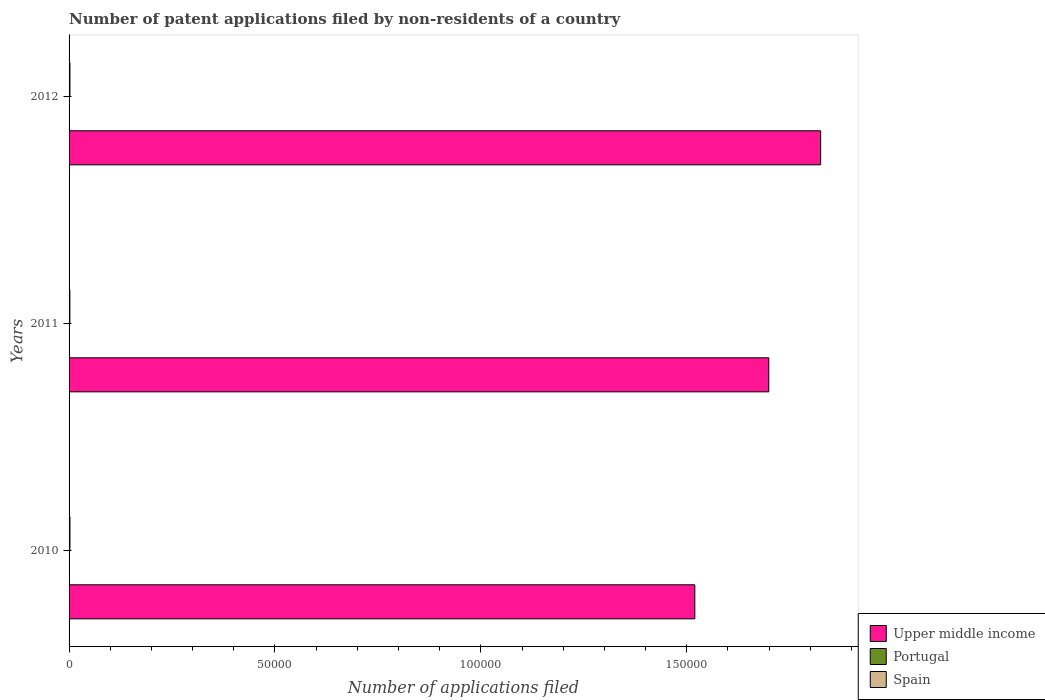Are the number of bars on each tick of the Y-axis equal?
Provide a succinct answer. Yes. How many bars are there on the 1st tick from the top?
Give a very brief answer. 3. How many bars are there on the 3rd tick from the bottom?
Give a very brief answer. 3. In how many cases, is the number of bars for a given year not equal to the number of legend labels?
Provide a short and direct response. 0. Across all years, what is the maximum number of applications filed in Upper middle income?
Offer a very short reply. 1.83e+05. Across all years, what is the minimum number of applications filed in Spain?
Give a very brief answer. 196. In which year was the number of applications filed in Spain minimum?
Your answer should be compact. 2011. What is the total number of applications filed in Portugal in the graph?
Offer a very short reply. 147. What is the difference between the number of applications filed in Spain in 2011 and that in 2012?
Ensure brevity in your answer.  -13. What is the difference between the number of applications filed in Spain in 2011 and the number of applications filed in Upper middle income in 2012?
Provide a short and direct response. -1.82e+05. What is the average number of applications filed in Upper middle income per year?
Ensure brevity in your answer.  1.68e+05. In the year 2010, what is the difference between the number of applications filed in Upper middle income and number of applications filed in Spain?
Provide a short and direct response. 1.52e+05. What is the ratio of the number of applications filed in Portugal in 2010 to that in 2011?
Give a very brief answer. 0.61. Is the number of applications filed in Portugal in 2010 less than that in 2012?
Provide a succinct answer. No. In how many years, is the number of applications filed in Portugal greater than the average number of applications filed in Portugal taken over all years?
Provide a succinct answer. 1. What does the 3rd bar from the top in 2012 represents?
Ensure brevity in your answer.  Upper middle income. How many bars are there?
Make the answer very short. 9. Are all the bars in the graph horizontal?
Your answer should be compact. Yes. What is the difference between two consecutive major ticks on the X-axis?
Ensure brevity in your answer.  5.00e+04. Are the values on the major ticks of X-axis written in scientific E-notation?
Offer a very short reply. No. Does the graph contain any zero values?
Offer a very short reply. No. Where does the legend appear in the graph?
Offer a terse response. Bottom right. How many legend labels are there?
Give a very brief answer. 3. What is the title of the graph?
Provide a short and direct response. Number of patent applications filed by non-residents of a country. What is the label or title of the X-axis?
Keep it short and to the point. Number of applications filed. What is the label or title of the Y-axis?
Offer a very short reply. Years. What is the Number of applications filed of Upper middle income in 2010?
Provide a short and direct response. 1.52e+05. What is the Number of applications filed in Portugal in 2010?
Your response must be concise. 46. What is the Number of applications filed of Spain in 2010?
Give a very brief answer. 213. What is the Number of applications filed in Upper middle income in 2011?
Your response must be concise. 1.70e+05. What is the Number of applications filed in Spain in 2011?
Offer a terse response. 196. What is the Number of applications filed of Upper middle income in 2012?
Your response must be concise. 1.83e+05. What is the Number of applications filed in Spain in 2012?
Your answer should be very brief. 209. Across all years, what is the maximum Number of applications filed of Upper middle income?
Keep it short and to the point. 1.83e+05. Across all years, what is the maximum Number of applications filed in Spain?
Ensure brevity in your answer.  213. Across all years, what is the minimum Number of applications filed of Upper middle income?
Give a very brief answer. 1.52e+05. Across all years, what is the minimum Number of applications filed of Spain?
Give a very brief answer. 196. What is the total Number of applications filed in Upper middle income in the graph?
Offer a very short reply. 5.04e+05. What is the total Number of applications filed of Portugal in the graph?
Provide a short and direct response. 147. What is the total Number of applications filed in Spain in the graph?
Provide a short and direct response. 618. What is the difference between the Number of applications filed in Upper middle income in 2010 and that in 2011?
Your response must be concise. -1.80e+04. What is the difference between the Number of applications filed in Spain in 2010 and that in 2011?
Your answer should be compact. 17. What is the difference between the Number of applications filed in Upper middle income in 2010 and that in 2012?
Your response must be concise. -3.06e+04. What is the difference between the Number of applications filed of Upper middle income in 2011 and that in 2012?
Your response must be concise. -1.26e+04. What is the difference between the Number of applications filed of Upper middle income in 2010 and the Number of applications filed of Portugal in 2011?
Offer a terse response. 1.52e+05. What is the difference between the Number of applications filed of Upper middle income in 2010 and the Number of applications filed of Spain in 2011?
Offer a very short reply. 1.52e+05. What is the difference between the Number of applications filed in Portugal in 2010 and the Number of applications filed in Spain in 2011?
Offer a very short reply. -150. What is the difference between the Number of applications filed of Upper middle income in 2010 and the Number of applications filed of Portugal in 2012?
Make the answer very short. 1.52e+05. What is the difference between the Number of applications filed in Upper middle income in 2010 and the Number of applications filed in Spain in 2012?
Your response must be concise. 1.52e+05. What is the difference between the Number of applications filed of Portugal in 2010 and the Number of applications filed of Spain in 2012?
Ensure brevity in your answer.  -163. What is the difference between the Number of applications filed in Upper middle income in 2011 and the Number of applications filed in Portugal in 2012?
Your answer should be compact. 1.70e+05. What is the difference between the Number of applications filed of Upper middle income in 2011 and the Number of applications filed of Spain in 2012?
Your response must be concise. 1.70e+05. What is the difference between the Number of applications filed of Portugal in 2011 and the Number of applications filed of Spain in 2012?
Your answer should be compact. -134. What is the average Number of applications filed in Upper middle income per year?
Give a very brief answer. 1.68e+05. What is the average Number of applications filed of Portugal per year?
Offer a very short reply. 49. What is the average Number of applications filed in Spain per year?
Provide a succinct answer. 206. In the year 2010, what is the difference between the Number of applications filed in Upper middle income and Number of applications filed in Portugal?
Offer a very short reply. 1.52e+05. In the year 2010, what is the difference between the Number of applications filed in Upper middle income and Number of applications filed in Spain?
Keep it short and to the point. 1.52e+05. In the year 2010, what is the difference between the Number of applications filed of Portugal and Number of applications filed of Spain?
Make the answer very short. -167. In the year 2011, what is the difference between the Number of applications filed of Upper middle income and Number of applications filed of Portugal?
Your answer should be very brief. 1.70e+05. In the year 2011, what is the difference between the Number of applications filed in Upper middle income and Number of applications filed in Spain?
Your answer should be very brief. 1.70e+05. In the year 2011, what is the difference between the Number of applications filed of Portugal and Number of applications filed of Spain?
Provide a short and direct response. -121. In the year 2012, what is the difference between the Number of applications filed of Upper middle income and Number of applications filed of Portugal?
Make the answer very short. 1.82e+05. In the year 2012, what is the difference between the Number of applications filed in Upper middle income and Number of applications filed in Spain?
Provide a succinct answer. 1.82e+05. In the year 2012, what is the difference between the Number of applications filed of Portugal and Number of applications filed of Spain?
Provide a short and direct response. -183. What is the ratio of the Number of applications filed in Upper middle income in 2010 to that in 2011?
Keep it short and to the point. 0.89. What is the ratio of the Number of applications filed of Portugal in 2010 to that in 2011?
Ensure brevity in your answer.  0.61. What is the ratio of the Number of applications filed of Spain in 2010 to that in 2011?
Your answer should be very brief. 1.09. What is the ratio of the Number of applications filed in Upper middle income in 2010 to that in 2012?
Your answer should be very brief. 0.83. What is the ratio of the Number of applications filed in Portugal in 2010 to that in 2012?
Keep it short and to the point. 1.77. What is the ratio of the Number of applications filed of Spain in 2010 to that in 2012?
Offer a terse response. 1.02. What is the ratio of the Number of applications filed of Portugal in 2011 to that in 2012?
Ensure brevity in your answer.  2.88. What is the ratio of the Number of applications filed of Spain in 2011 to that in 2012?
Your response must be concise. 0.94. What is the difference between the highest and the second highest Number of applications filed in Upper middle income?
Keep it short and to the point. 1.26e+04. What is the difference between the highest and the second highest Number of applications filed of Portugal?
Ensure brevity in your answer.  29. What is the difference between the highest and the second highest Number of applications filed in Spain?
Provide a succinct answer. 4. What is the difference between the highest and the lowest Number of applications filed in Upper middle income?
Keep it short and to the point. 3.06e+04. What is the difference between the highest and the lowest Number of applications filed of Spain?
Offer a terse response. 17. 